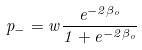<formula> <loc_0><loc_0><loc_500><loc_500>p _ { - } = w \frac { e ^ { - 2 \beta _ { o } } } { 1 + e ^ { - 2 \beta _ { o } } }</formula> 